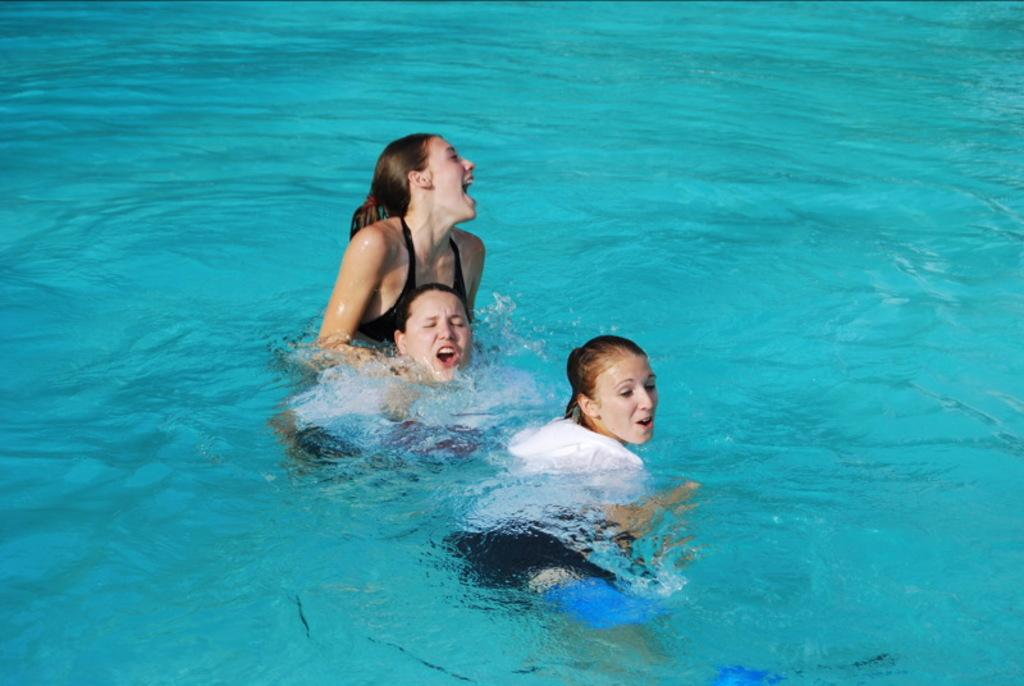Who is present in the image? There are women in the image. What is the setting of the image? The women are in water. What form of disgust can be seen on the women's faces in the image? There is no indication of disgust on the women's faces in the image. 